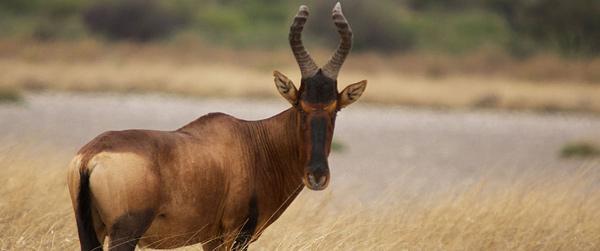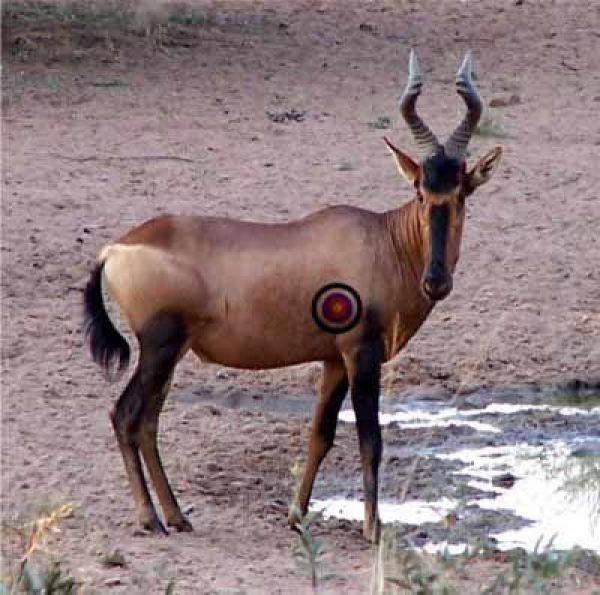The first image is the image on the left, the second image is the image on the right. For the images displayed, is the sentence "A hunter in camo is posed behind a downed long-horned animal, with his weapon propped against the animal's front." factually correct? Answer yes or no. No. The first image is the image on the left, the second image is the image on the right. Assess this claim about the two images: "At least one of the images shows a human posing behind a horned animal.". Correct or not? Answer yes or no. No. 